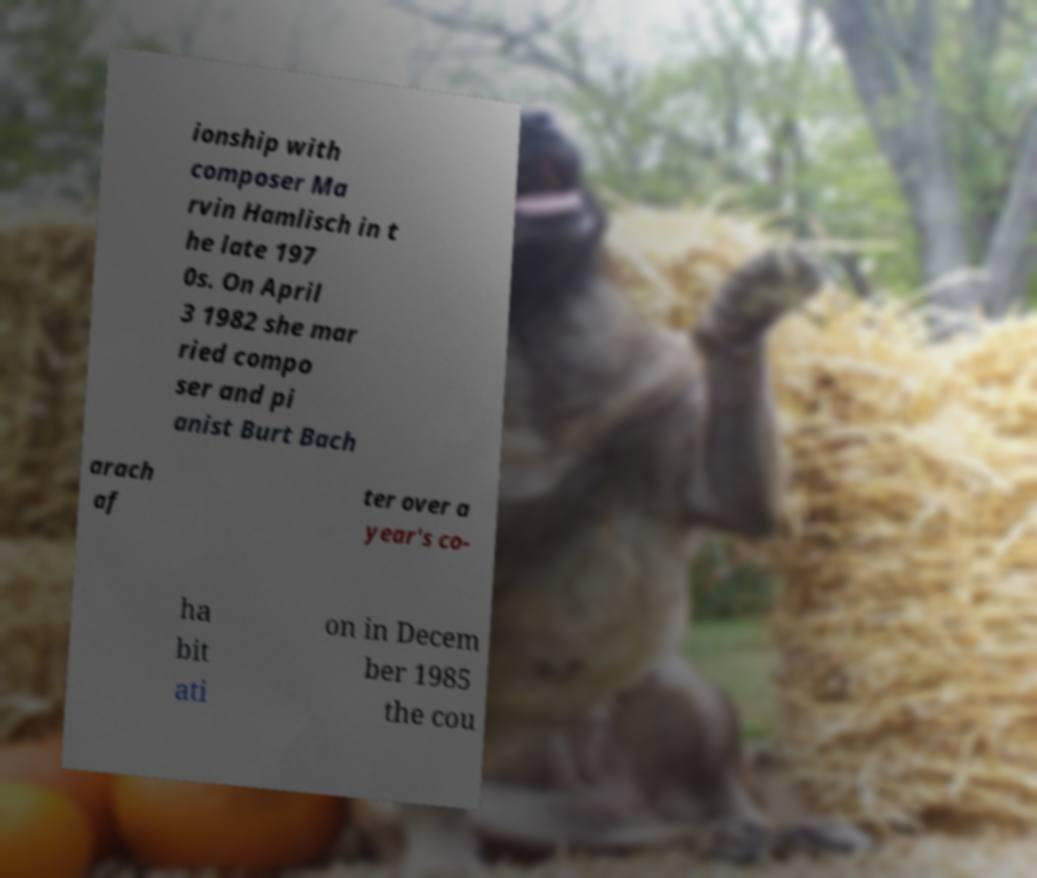Could you assist in decoding the text presented in this image and type it out clearly? ionship with composer Ma rvin Hamlisch in t he late 197 0s. On April 3 1982 she mar ried compo ser and pi anist Burt Bach arach af ter over a year's co- ha bit ati on in Decem ber 1985 the cou 